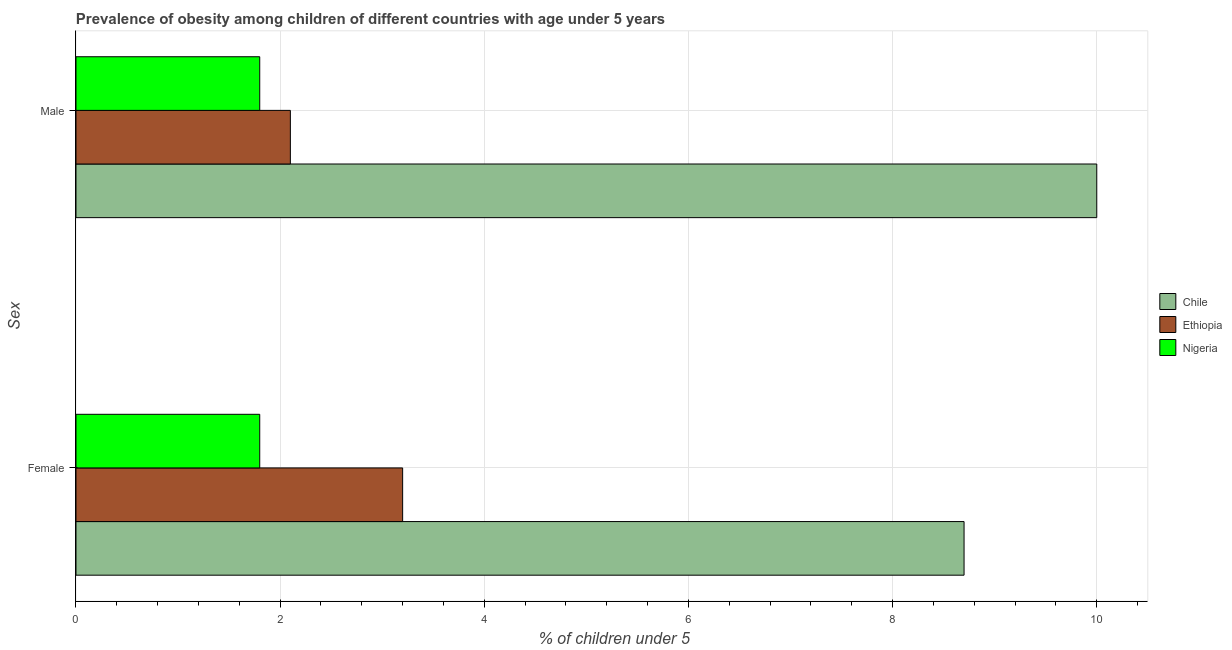Are the number of bars per tick equal to the number of legend labels?
Give a very brief answer. Yes. Are the number of bars on each tick of the Y-axis equal?
Your answer should be compact. Yes. How many bars are there on the 2nd tick from the top?
Provide a short and direct response. 3. What is the label of the 1st group of bars from the top?
Your answer should be compact. Male. What is the percentage of obese female children in Nigeria?
Give a very brief answer. 1.8. Across all countries, what is the maximum percentage of obese female children?
Provide a succinct answer. 8.7. Across all countries, what is the minimum percentage of obese male children?
Offer a very short reply. 1.8. In which country was the percentage of obese male children minimum?
Offer a very short reply. Nigeria. What is the total percentage of obese female children in the graph?
Offer a very short reply. 13.7. What is the difference between the percentage of obese male children in Chile and that in Ethiopia?
Make the answer very short. 7.9. What is the difference between the percentage of obese female children in Nigeria and the percentage of obese male children in Chile?
Provide a short and direct response. -8.2. What is the average percentage of obese female children per country?
Your answer should be very brief. 4.57. What is the difference between the percentage of obese male children and percentage of obese female children in Chile?
Provide a short and direct response. 1.3. In how many countries, is the percentage of obese male children greater than 7.2 %?
Offer a very short reply. 1. What is the ratio of the percentage of obese female children in Chile to that in Ethiopia?
Make the answer very short. 2.72. What does the 2nd bar from the top in Male represents?
Make the answer very short. Ethiopia. What does the 1st bar from the bottom in Male represents?
Offer a very short reply. Chile. How many bars are there?
Keep it short and to the point. 6. Are all the bars in the graph horizontal?
Your answer should be very brief. Yes. How many countries are there in the graph?
Your response must be concise. 3. What is the difference between two consecutive major ticks on the X-axis?
Provide a short and direct response. 2. Are the values on the major ticks of X-axis written in scientific E-notation?
Offer a very short reply. No. Where does the legend appear in the graph?
Make the answer very short. Center right. How many legend labels are there?
Give a very brief answer. 3. What is the title of the graph?
Your answer should be very brief. Prevalence of obesity among children of different countries with age under 5 years. Does "Ecuador" appear as one of the legend labels in the graph?
Your response must be concise. No. What is the label or title of the X-axis?
Your answer should be compact.  % of children under 5. What is the label or title of the Y-axis?
Provide a short and direct response. Sex. What is the  % of children under 5 in Chile in Female?
Provide a short and direct response. 8.7. What is the  % of children under 5 in Ethiopia in Female?
Your response must be concise. 3.2. What is the  % of children under 5 of Nigeria in Female?
Your answer should be very brief. 1.8. What is the  % of children under 5 in Chile in Male?
Provide a succinct answer. 10. What is the  % of children under 5 of Ethiopia in Male?
Offer a terse response. 2.1. What is the  % of children under 5 of Nigeria in Male?
Your response must be concise. 1.8. Across all Sex, what is the maximum  % of children under 5 in Chile?
Make the answer very short. 10. Across all Sex, what is the maximum  % of children under 5 in Ethiopia?
Your response must be concise. 3.2. Across all Sex, what is the maximum  % of children under 5 in Nigeria?
Your answer should be very brief. 1.8. Across all Sex, what is the minimum  % of children under 5 in Chile?
Ensure brevity in your answer.  8.7. Across all Sex, what is the minimum  % of children under 5 in Ethiopia?
Offer a very short reply. 2.1. Across all Sex, what is the minimum  % of children under 5 of Nigeria?
Give a very brief answer. 1.8. What is the total  % of children under 5 in Chile in the graph?
Provide a succinct answer. 18.7. What is the difference between the  % of children under 5 in Chile in Female and that in Male?
Offer a terse response. -1.3. What is the difference between the  % of children under 5 in Ethiopia in Female and that in Male?
Offer a very short reply. 1.1. What is the difference between the  % of children under 5 in Chile in Female and the  % of children under 5 in Ethiopia in Male?
Your answer should be very brief. 6.6. What is the difference between the  % of children under 5 of Chile in Female and the  % of children under 5 of Nigeria in Male?
Your answer should be compact. 6.9. What is the average  % of children under 5 of Chile per Sex?
Offer a very short reply. 9.35. What is the average  % of children under 5 in Ethiopia per Sex?
Offer a very short reply. 2.65. What is the difference between the  % of children under 5 of Chile and  % of children under 5 of Nigeria in Female?
Ensure brevity in your answer.  6.9. What is the difference between the  % of children under 5 in Ethiopia and  % of children under 5 in Nigeria in Female?
Keep it short and to the point. 1.4. What is the difference between the  % of children under 5 of Ethiopia and  % of children under 5 of Nigeria in Male?
Provide a succinct answer. 0.3. What is the ratio of the  % of children under 5 in Chile in Female to that in Male?
Ensure brevity in your answer.  0.87. What is the ratio of the  % of children under 5 of Ethiopia in Female to that in Male?
Provide a short and direct response. 1.52. What is the ratio of the  % of children under 5 in Nigeria in Female to that in Male?
Make the answer very short. 1. What is the difference between the highest and the second highest  % of children under 5 in Chile?
Provide a short and direct response. 1.3. What is the difference between the highest and the second highest  % of children under 5 of Ethiopia?
Ensure brevity in your answer.  1.1. What is the difference between the highest and the lowest  % of children under 5 in Chile?
Your answer should be compact. 1.3. 